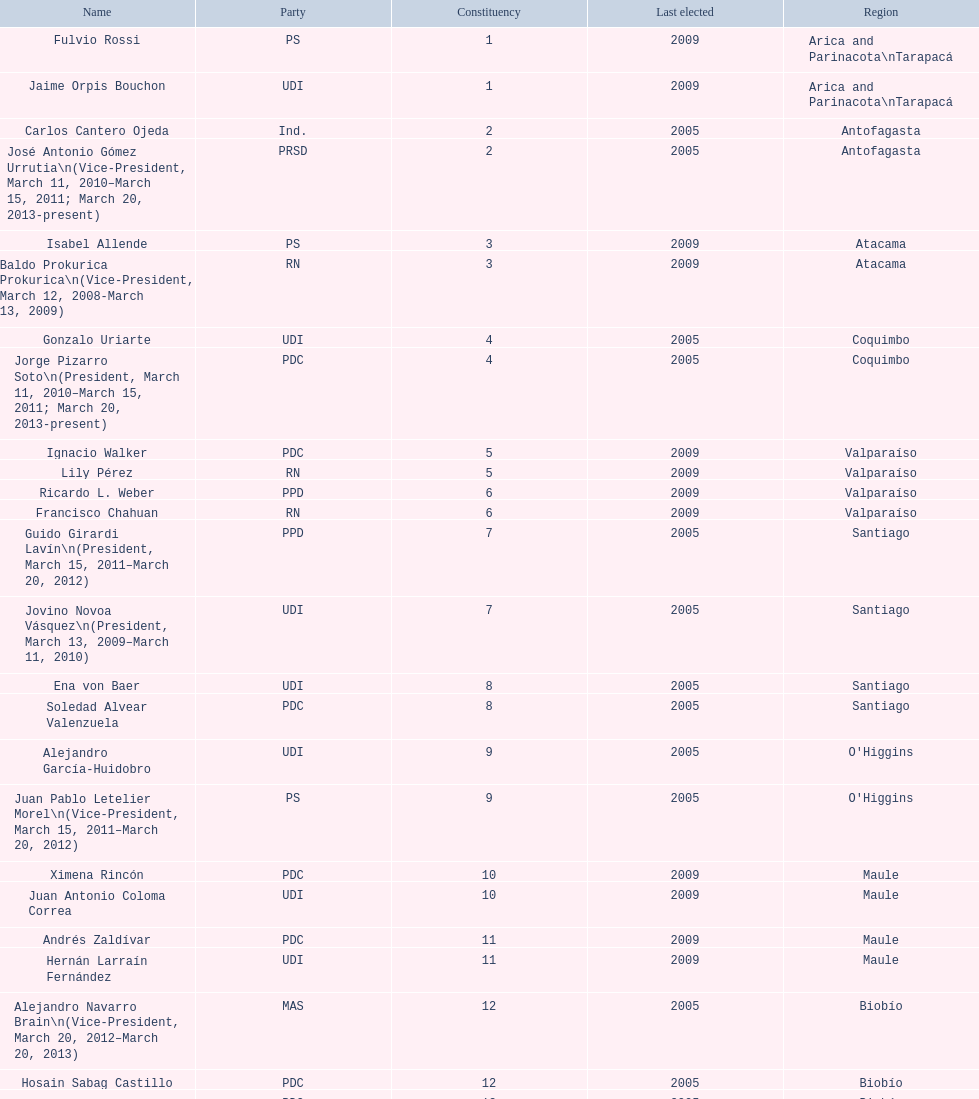When was antonio horvath kiss last elected? 2001. 